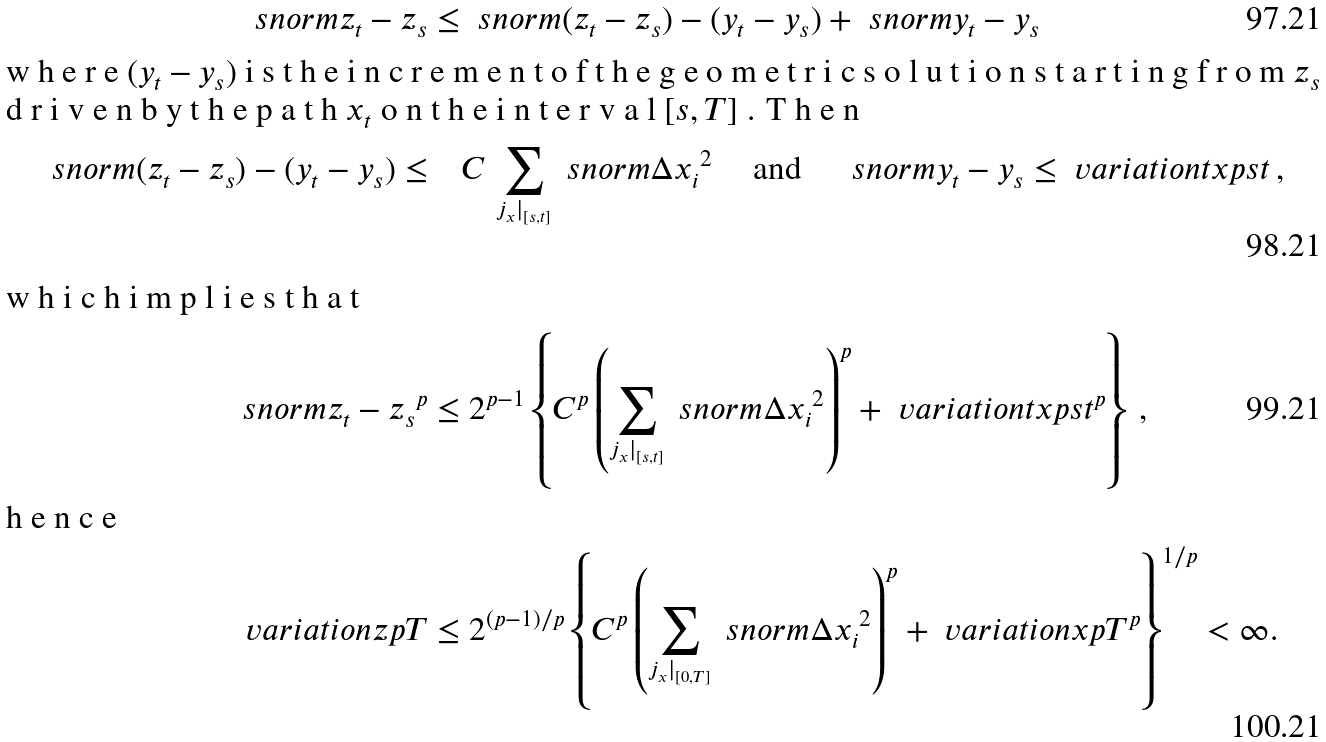<formula> <loc_0><loc_0><loc_500><loc_500>\ s n o r m { z _ { t } - z _ { s } } & \leq \ s n o r m { ( z _ { t } - z _ { s } ) - ( y _ { t } - y _ { s } ) } + \ s n o r m { y _ { t } - y _ { s } } \\ \intertext { w h e r e $ ( y _ { t } - y _ { s } ) $ i s t h e i n c r e m e n t o f t h e g e o m e t r i c s o l u t i o n s t a r t i n g f r o m $ z _ { s } $ d r i v e n b y t h e p a t h $ x _ { t } $ o n t h e i n t e r v a l $ [ s , T ] $ . T h e n } \ s n o r m { ( z _ { t } - z _ { s } ) - ( y _ { t } - y _ { s } ) } \leq & \quad C \, \sum _ { \substack { j _ { x } | _ { [ s , t ] } } } \ s n o r m { \Delta x _ { i } } ^ { 2 } \quad \text { and } \quad \ s n o r m { y _ { t } - y _ { s } } \leq \ v a r i a t i o n t { x } { p } { s } { t } \, , \\ \intertext { w h i c h i m p l i e s t h a t } \ s n o r m { z _ { t } - z _ { s } } ^ { p } & \leq 2 ^ { p - 1 } \left \{ C ^ { p } \left ( \sum _ { \substack { j _ { x } | _ { [ s , t ] } } } \ s n o r m { \Delta x _ { i } } ^ { 2 } \right ) ^ { p } + \ v a r i a t i o n t { x } { p } { s } { t } ^ { p } \right \} \, , \\ \intertext { h e n c e } \ v a r i a t i o n { z } { p } { T } & \leq 2 ^ { ( p - 1 ) / p } \left \{ C ^ { p } \left ( \sum _ { \substack { j _ { x } | _ { [ 0 , T ] } } } \ s n o r m { \Delta x _ { i } } ^ { 2 } \right ) ^ { p } + \ v a r i a t i o n { x } { p } { T } ^ { p } \right \} ^ { 1 / p } < \infty .</formula> 